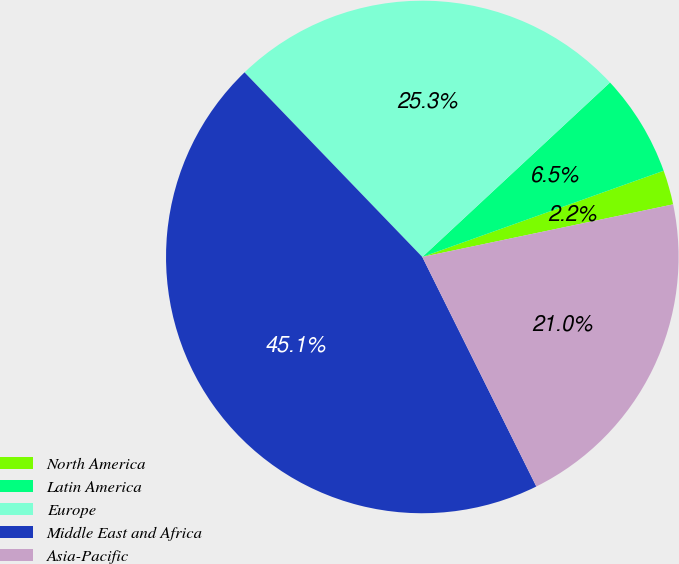<chart> <loc_0><loc_0><loc_500><loc_500><pie_chart><fcel>North America<fcel>Latin America<fcel>Europe<fcel>Middle East and Africa<fcel>Asia-Pacific<nl><fcel>2.17%<fcel>6.46%<fcel>25.28%<fcel>45.14%<fcel>20.95%<nl></chart> 